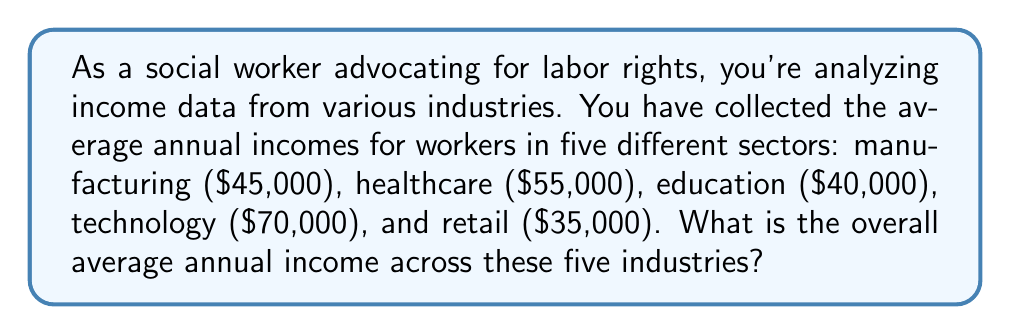Can you answer this question? To solve this problem, we need to calculate the arithmetic mean of the given incomes. The formula for the arithmetic mean is:

$$ \text{Average} = \frac{\text{Sum of all values}}{\text{Number of values}} $$

Let's follow these steps:

1. Sum up all the average incomes:
   $45,000 + 55,000 + 40,000 + 70,000 + 35,000 = 245,000$

2. Count the number of industries: 5

3. Apply the formula:
   $$ \text{Average Income} = \frac{245,000}{5} = 49,000 $$

Therefore, the overall average annual income across these five industries is $49,000.
Answer: $49,000 